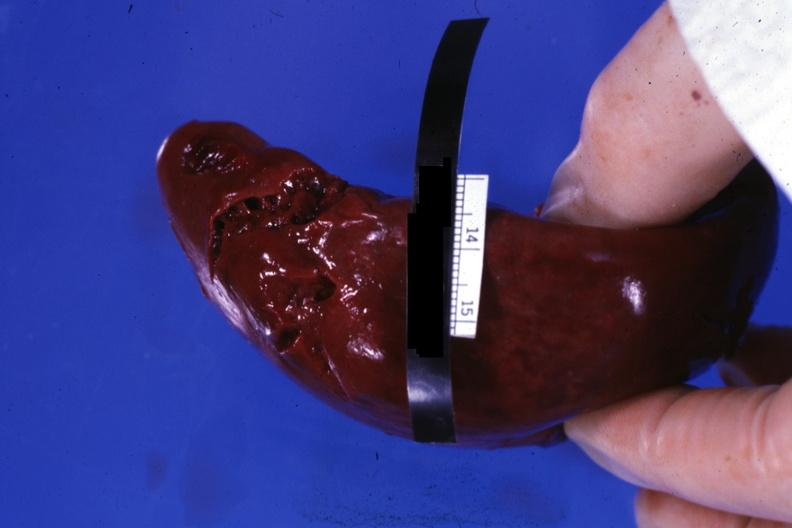what is present?
Answer the question using a single word or phrase. Spleen 